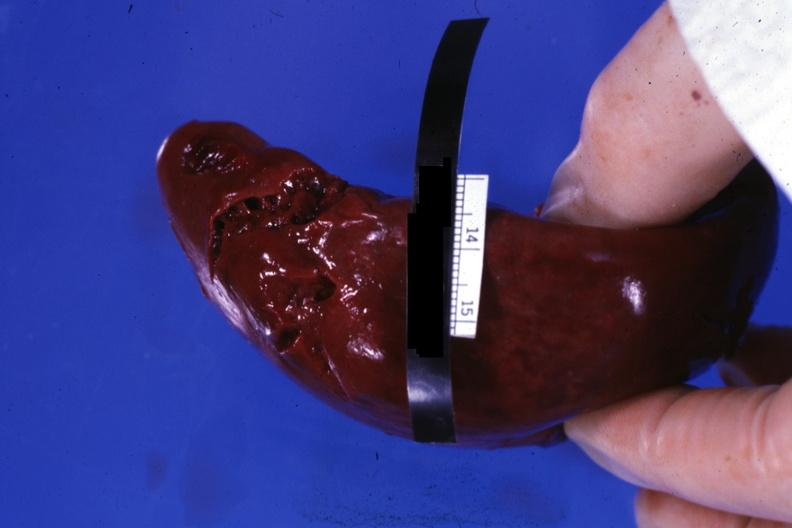what is present?
Answer the question using a single word or phrase. Spleen 